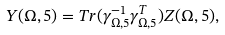<formula> <loc_0><loc_0><loc_500><loc_500>Y ( \Omega , 5 ) = T r ( \gamma _ { \Omega , 5 } ^ { - 1 } \gamma _ { \Omega , 5 } ^ { T } ) Z ( \Omega , 5 ) ,</formula> 